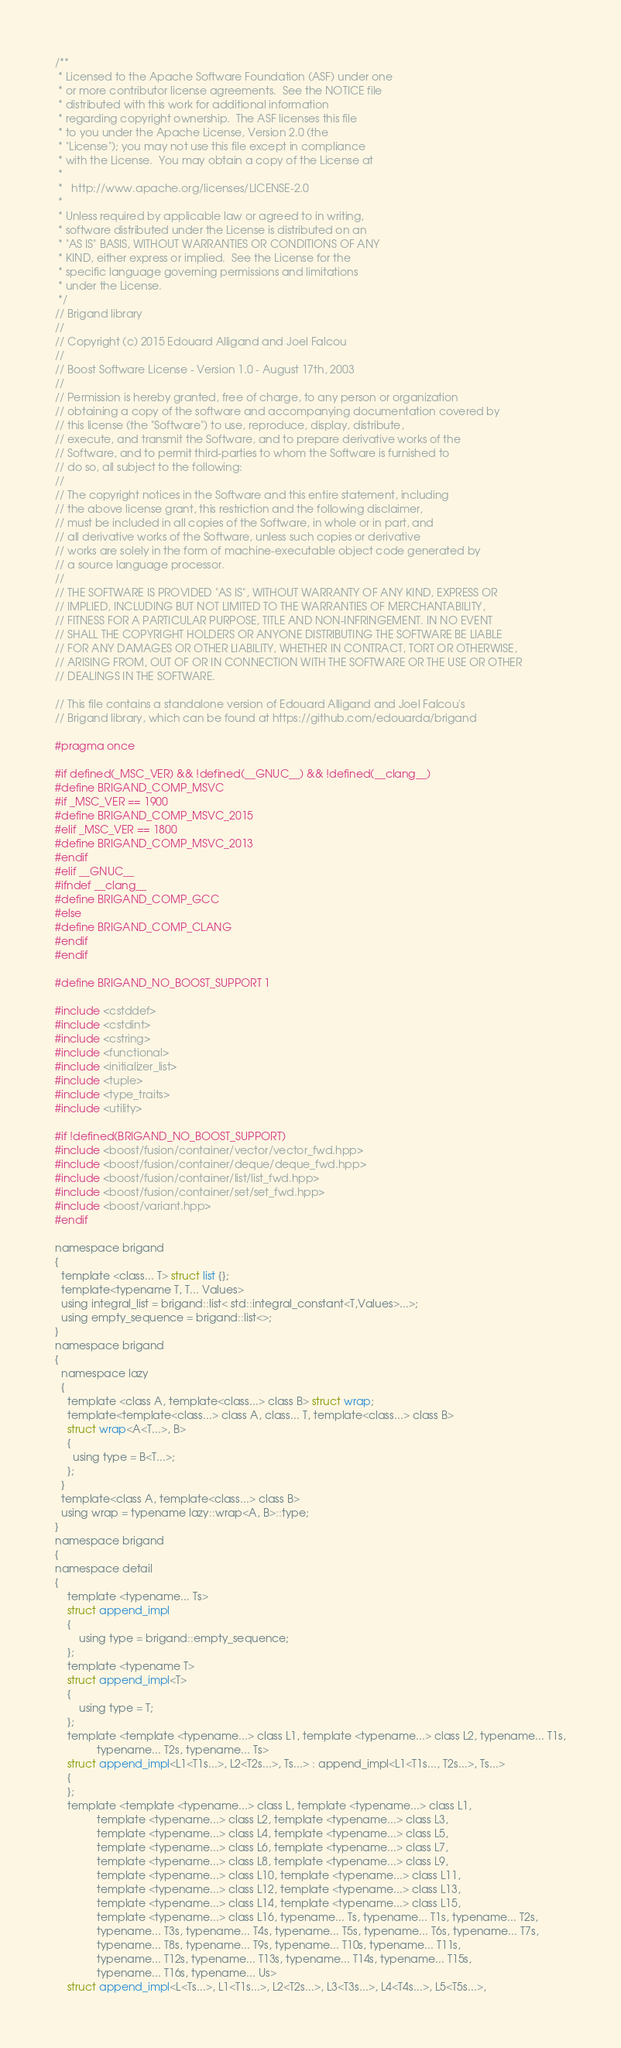<code> <loc_0><loc_0><loc_500><loc_500><_C_>/**
 * Licensed to the Apache Software Foundation (ASF) under one
 * or more contributor license agreements.  See the NOTICE file
 * distributed with this work for additional information
 * regarding copyright ownership.  The ASF licenses this file
 * to you under the Apache License, Version 2.0 (the
 * "License"); you may not use this file except in compliance
 * with the License.  You may obtain a copy of the License at
 *
 *   http://www.apache.org/licenses/LICENSE-2.0
 *
 * Unless required by applicable law or agreed to in writing,
 * software distributed under the License is distributed on an
 * "AS IS" BASIS, WITHOUT WARRANTIES OR CONDITIONS OF ANY
 * KIND, either express or implied.  See the License for the
 * specific language governing permissions and limitations
 * under the License.
 */
// Brigand library
//
// Copyright (c) 2015 Edouard Alligand and Joel Falcou
//
// Boost Software License - Version 1.0 - August 17th, 2003
//
// Permission is hereby granted, free of charge, to any person or organization
// obtaining a copy of the software and accompanying documentation covered by
// this license (the "Software") to use, reproduce, display, distribute,
// execute, and transmit the Software, and to prepare derivative works of the
// Software, and to permit third-parties to whom the Software is furnished to
// do so, all subject to the following:
//
// The copyright notices in the Software and this entire statement, including
// the above license grant, this restriction and the following disclaimer,
// must be included in all copies of the Software, in whole or in part, and
// all derivative works of the Software, unless such copies or derivative
// works are solely in the form of machine-executable object code generated by
// a source language processor.
//
// THE SOFTWARE IS PROVIDED "AS IS", WITHOUT WARRANTY OF ANY KIND, EXPRESS OR
// IMPLIED, INCLUDING BUT NOT LIMITED TO THE WARRANTIES OF MERCHANTABILITY,
// FITNESS FOR A PARTICULAR PURPOSE, TITLE AND NON-INFRINGEMENT. IN NO EVENT
// SHALL THE COPYRIGHT HOLDERS OR ANYONE DISTRIBUTING THE SOFTWARE BE LIABLE
// FOR ANY DAMAGES OR OTHER LIABILITY, WHETHER IN CONTRACT, TORT OR OTHERWISE,
// ARISING FROM, OUT OF OR IN CONNECTION WITH THE SOFTWARE OR THE USE OR OTHER
// DEALINGS IN THE SOFTWARE.

// This file contains a standalone version of Edouard Alligand and Joel Falcou's 
// Brigand library, which can be found at https://github.com/edouarda/brigand

#pragma once

#if defined(_MSC_VER) && !defined(__GNUC__) && !defined(__clang__)
#define BRIGAND_COMP_MSVC
#if _MSC_VER == 1900
#define BRIGAND_COMP_MSVC_2015
#elif _MSC_VER == 1800
#define BRIGAND_COMP_MSVC_2013
#endif
#elif __GNUC__
#ifndef __clang__
#define BRIGAND_COMP_GCC
#else
#define BRIGAND_COMP_CLANG
#endif
#endif

#define BRIGAND_NO_BOOST_SUPPORT 1

#include <cstddef>
#include <cstdint>
#include <cstring>
#include <functional>
#include <initializer_list>
#include <tuple>
#include <type_traits>
#include <utility>

#if !defined(BRIGAND_NO_BOOST_SUPPORT)
#include <boost/fusion/container/vector/vector_fwd.hpp>
#include <boost/fusion/container/deque/deque_fwd.hpp>
#include <boost/fusion/container/list/list_fwd.hpp>
#include <boost/fusion/container/set/set_fwd.hpp>
#include <boost/variant.hpp>
#endif

namespace brigand
{
  template <class... T> struct list {};
  template<typename T, T... Values>
  using integral_list = brigand::list< std::integral_constant<T,Values>...>;
  using empty_sequence = brigand::list<>;
}
namespace brigand
{
  namespace lazy
  {
    template <class A, template<class...> class B> struct wrap;
    template<template<class...> class A, class... T, template<class...> class B>
    struct wrap<A<T...>, B>
    {
      using type = B<T...>;
    };
  }
  template<class A, template<class...> class B>
  using wrap = typename lazy::wrap<A, B>::type;
}
namespace brigand
{
namespace detail
{
    template <typename... Ts>
    struct append_impl
    {
        using type = brigand::empty_sequence;
    };
    template <typename T>
    struct append_impl<T>
    {
        using type = T;
    };
    template <template <typename...> class L1, template <typename...> class L2, typename... T1s,
              typename... T2s, typename... Ts>
    struct append_impl<L1<T1s...>, L2<T2s...>, Ts...> : append_impl<L1<T1s..., T2s...>, Ts...>
    {
    };
    template <template <typename...> class L, template <typename...> class L1,
              template <typename...> class L2, template <typename...> class L3,
              template <typename...> class L4, template <typename...> class L5,
              template <typename...> class L6, template <typename...> class L7,
              template <typename...> class L8, template <typename...> class L9,
              template <typename...> class L10, template <typename...> class L11,
              template <typename...> class L12, template <typename...> class L13,
              template <typename...> class L14, template <typename...> class L15,
              template <typename...> class L16, typename... Ts, typename... T1s, typename... T2s,
              typename... T3s, typename... T4s, typename... T5s, typename... T6s, typename... T7s,
              typename... T8s, typename... T9s, typename... T10s, typename... T11s,
              typename... T12s, typename... T13s, typename... T14s, typename... T15s,
              typename... T16s, typename... Us>
    struct append_impl<L<Ts...>, L1<T1s...>, L2<T2s...>, L3<T3s...>, L4<T4s...>, L5<T5s...>,</code> 